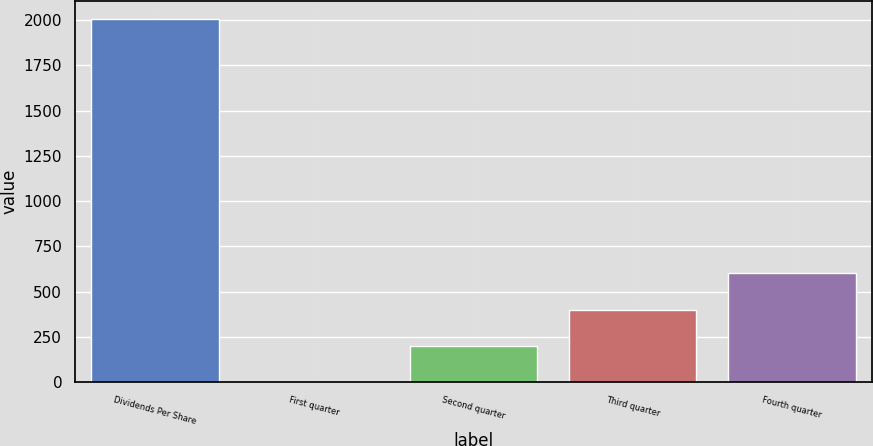Convert chart to OTSL. <chart><loc_0><loc_0><loc_500><loc_500><bar_chart><fcel>Dividends Per Share<fcel>First quarter<fcel>Second quarter<fcel>Third quarter<fcel>Fourth quarter<nl><fcel>2006<fcel>0.21<fcel>200.79<fcel>401.37<fcel>601.95<nl></chart> 